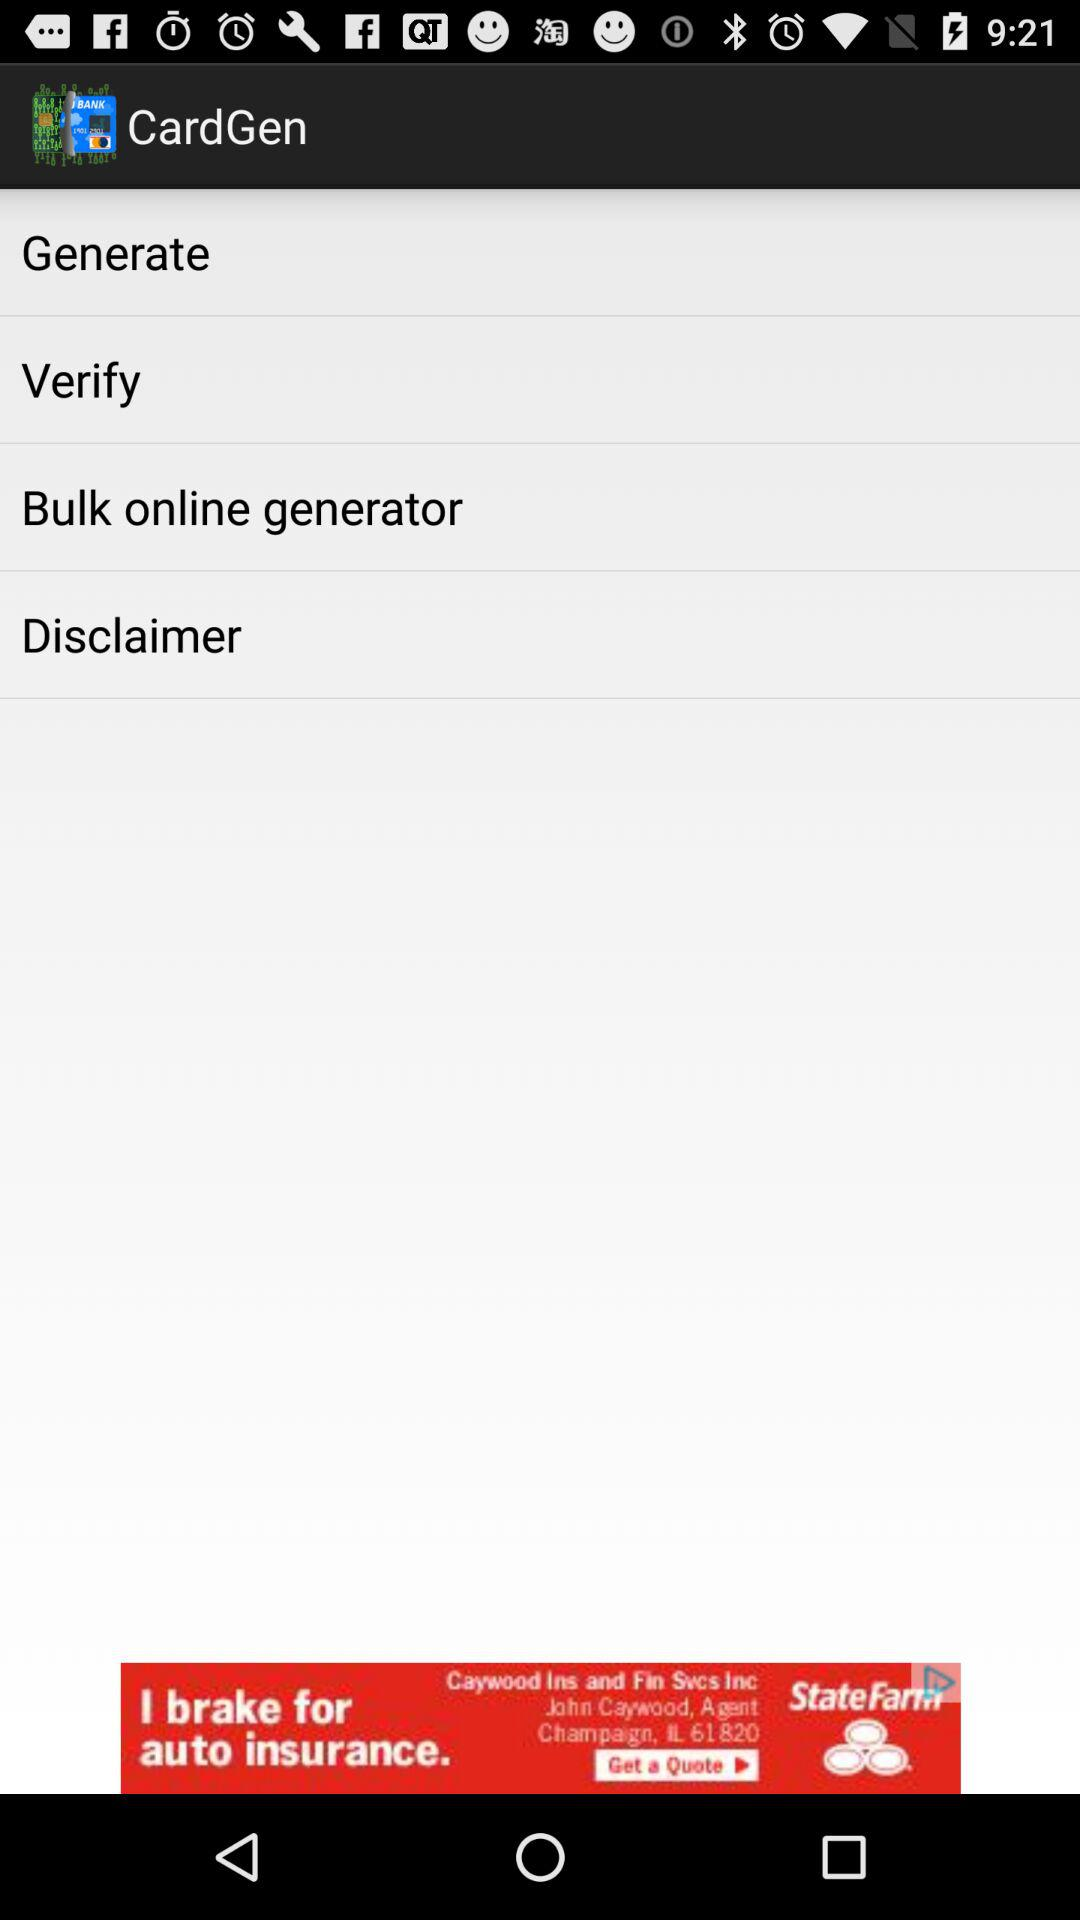What is the application name? The application name is "CardGen". 